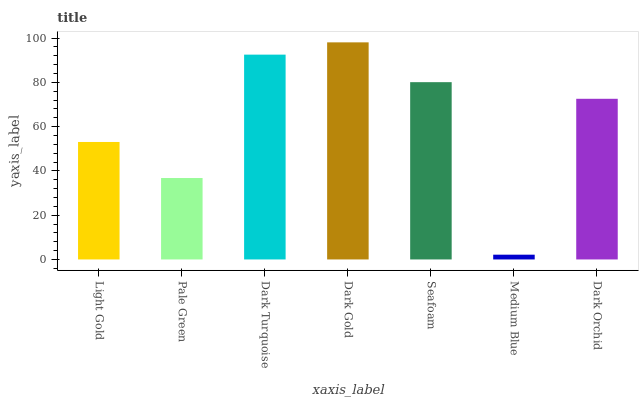Is Medium Blue the minimum?
Answer yes or no. Yes. Is Dark Gold the maximum?
Answer yes or no. Yes. Is Pale Green the minimum?
Answer yes or no. No. Is Pale Green the maximum?
Answer yes or no. No. Is Light Gold greater than Pale Green?
Answer yes or no. Yes. Is Pale Green less than Light Gold?
Answer yes or no. Yes. Is Pale Green greater than Light Gold?
Answer yes or no. No. Is Light Gold less than Pale Green?
Answer yes or no. No. Is Dark Orchid the high median?
Answer yes or no. Yes. Is Dark Orchid the low median?
Answer yes or no. Yes. Is Light Gold the high median?
Answer yes or no. No. Is Seafoam the low median?
Answer yes or no. No. 